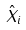<formula> <loc_0><loc_0><loc_500><loc_500>\hat { X } _ { i }</formula> 